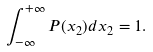Convert formula to latex. <formula><loc_0><loc_0><loc_500><loc_500>\int _ { - \infty } ^ { + \infty } P ( x _ { 2 } ) d x _ { 2 } = 1 .</formula> 